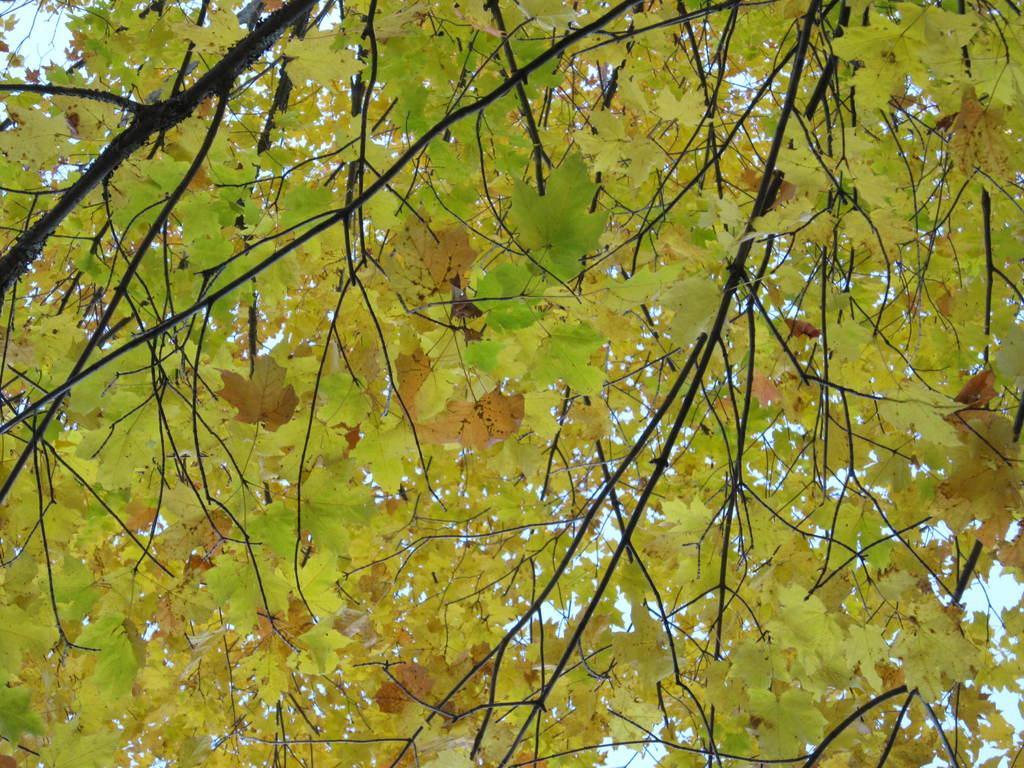How would you summarize this image in a sentence or two? This picture is clicked outside. In the foreground we can see the leaves of a tree and some other objects. In the background we can see the sky. 